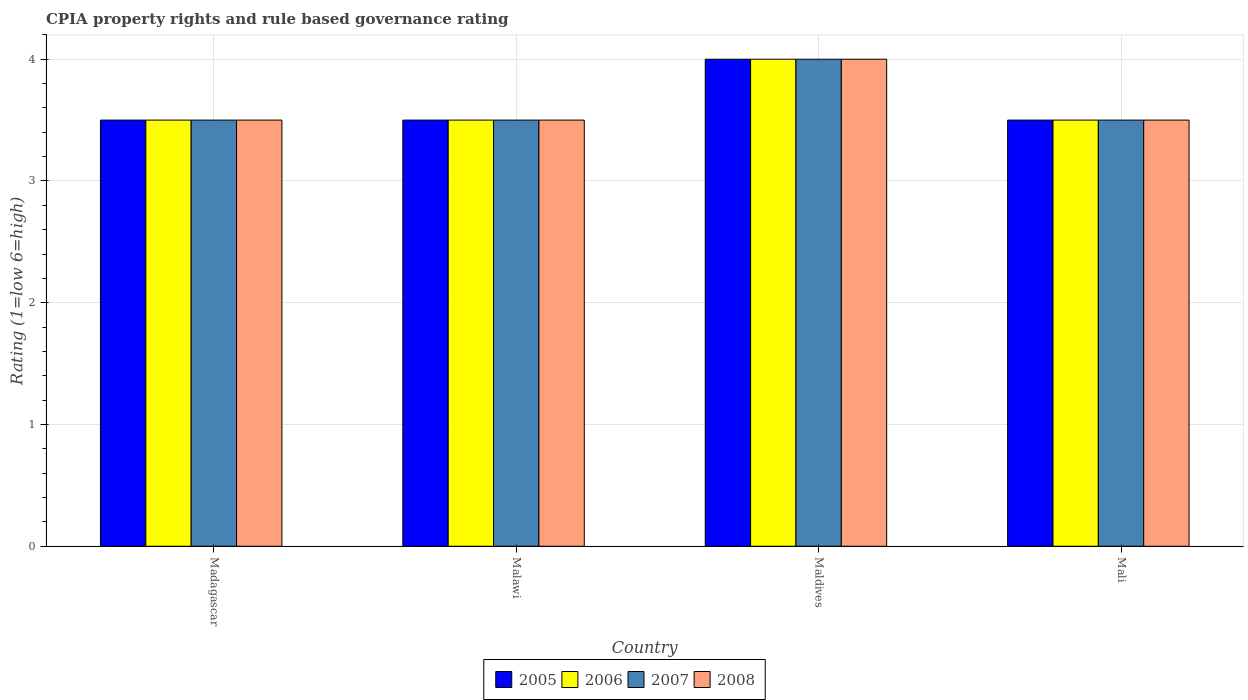How many groups of bars are there?
Offer a terse response. 4. How many bars are there on the 4th tick from the left?
Ensure brevity in your answer.  4. How many bars are there on the 1st tick from the right?
Your response must be concise. 4. What is the label of the 1st group of bars from the left?
Give a very brief answer. Madagascar. In how many cases, is the number of bars for a given country not equal to the number of legend labels?
Ensure brevity in your answer.  0. In which country was the CPIA rating in 2005 maximum?
Your answer should be very brief. Maldives. In which country was the CPIA rating in 2007 minimum?
Your response must be concise. Madagascar. What is the total CPIA rating in 2006 in the graph?
Offer a terse response. 14.5. What is the difference between the CPIA rating in 2007 in Mali and the CPIA rating in 2008 in Madagascar?
Provide a succinct answer. 0. What is the average CPIA rating in 2007 per country?
Your answer should be compact. 3.62. What is the difference between the CPIA rating of/in 2008 and CPIA rating of/in 2005 in Maldives?
Give a very brief answer. 0. In how many countries, is the CPIA rating in 2006 greater than 2.4?
Offer a very short reply. 4. What is the difference between the highest and the second highest CPIA rating in 2007?
Keep it short and to the point. -0.5. What is the difference between the highest and the lowest CPIA rating in 2005?
Your answer should be very brief. 0.5. In how many countries, is the CPIA rating in 2008 greater than the average CPIA rating in 2008 taken over all countries?
Give a very brief answer. 1. Is it the case that in every country, the sum of the CPIA rating in 2008 and CPIA rating in 2005 is greater than the sum of CPIA rating in 2006 and CPIA rating in 2007?
Your answer should be compact. No. What does the 2nd bar from the left in Mali represents?
Offer a very short reply. 2006. Are the values on the major ticks of Y-axis written in scientific E-notation?
Give a very brief answer. No. Where does the legend appear in the graph?
Offer a very short reply. Bottom center. How many legend labels are there?
Offer a very short reply. 4. How are the legend labels stacked?
Your answer should be compact. Horizontal. What is the title of the graph?
Your answer should be very brief. CPIA property rights and rule based governance rating. Does "1977" appear as one of the legend labels in the graph?
Offer a very short reply. No. What is the label or title of the X-axis?
Your answer should be very brief. Country. What is the Rating (1=low 6=high) of 2006 in Madagascar?
Keep it short and to the point. 3.5. What is the Rating (1=low 6=high) in 2007 in Madagascar?
Provide a succinct answer. 3.5. What is the Rating (1=low 6=high) of 2008 in Madagascar?
Your answer should be very brief. 3.5. What is the Rating (1=low 6=high) in 2005 in Malawi?
Give a very brief answer. 3.5. What is the Rating (1=low 6=high) of 2006 in Malawi?
Provide a short and direct response. 3.5. What is the Rating (1=low 6=high) in 2007 in Malawi?
Provide a short and direct response. 3.5. What is the Rating (1=low 6=high) of 2008 in Malawi?
Offer a terse response. 3.5. What is the Rating (1=low 6=high) in 2005 in Maldives?
Your response must be concise. 4. What is the Rating (1=low 6=high) in 2006 in Maldives?
Offer a very short reply. 4. What is the Rating (1=low 6=high) of 2005 in Mali?
Provide a succinct answer. 3.5. What is the Rating (1=low 6=high) in 2006 in Mali?
Give a very brief answer. 3.5. Across all countries, what is the maximum Rating (1=low 6=high) in 2006?
Keep it short and to the point. 4. Across all countries, what is the maximum Rating (1=low 6=high) of 2008?
Offer a terse response. 4. Across all countries, what is the minimum Rating (1=low 6=high) in 2006?
Your response must be concise. 3.5. What is the total Rating (1=low 6=high) in 2005 in the graph?
Keep it short and to the point. 14.5. What is the total Rating (1=low 6=high) in 2007 in the graph?
Provide a succinct answer. 14.5. What is the total Rating (1=low 6=high) of 2008 in the graph?
Provide a succinct answer. 14.5. What is the difference between the Rating (1=low 6=high) of 2006 in Madagascar and that in Malawi?
Offer a very short reply. 0. What is the difference between the Rating (1=low 6=high) in 2005 in Madagascar and that in Maldives?
Make the answer very short. -0.5. What is the difference between the Rating (1=low 6=high) of 2006 in Madagascar and that in Maldives?
Your response must be concise. -0.5. What is the difference between the Rating (1=low 6=high) in 2008 in Madagascar and that in Maldives?
Your answer should be very brief. -0.5. What is the difference between the Rating (1=low 6=high) in 2005 in Madagascar and that in Mali?
Your answer should be very brief. 0. What is the difference between the Rating (1=low 6=high) in 2006 in Madagascar and that in Mali?
Offer a terse response. 0. What is the difference between the Rating (1=low 6=high) of 2007 in Madagascar and that in Mali?
Your answer should be very brief. 0. What is the difference between the Rating (1=low 6=high) in 2008 in Madagascar and that in Mali?
Your response must be concise. 0. What is the difference between the Rating (1=low 6=high) in 2007 in Malawi and that in Maldives?
Provide a succinct answer. -0.5. What is the difference between the Rating (1=low 6=high) of 2006 in Malawi and that in Mali?
Your answer should be very brief. 0. What is the difference between the Rating (1=low 6=high) in 2007 in Malawi and that in Mali?
Provide a short and direct response. 0. What is the difference between the Rating (1=low 6=high) in 2008 in Malawi and that in Mali?
Your answer should be compact. 0. What is the difference between the Rating (1=low 6=high) in 2005 in Maldives and that in Mali?
Ensure brevity in your answer.  0.5. What is the difference between the Rating (1=low 6=high) in 2006 in Maldives and that in Mali?
Provide a short and direct response. 0.5. What is the difference between the Rating (1=low 6=high) in 2008 in Maldives and that in Mali?
Provide a succinct answer. 0.5. What is the difference between the Rating (1=low 6=high) of 2005 in Madagascar and the Rating (1=low 6=high) of 2006 in Malawi?
Your answer should be very brief. 0. What is the difference between the Rating (1=low 6=high) in 2005 in Madagascar and the Rating (1=low 6=high) in 2007 in Malawi?
Provide a short and direct response. 0. What is the difference between the Rating (1=low 6=high) in 2005 in Madagascar and the Rating (1=low 6=high) in 2008 in Malawi?
Provide a short and direct response. 0. What is the difference between the Rating (1=low 6=high) of 2006 in Madagascar and the Rating (1=low 6=high) of 2008 in Malawi?
Your answer should be very brief. 0. What is the difference between the Rating (1=low 6=high) of 2007 in Madagascar and the Rating (1=low 6=high) of 2008 in Malawi?
Make the answer very short. 0. What is the difference between the Rating (1=low 6=high) of 2005 in Madagascar and the Rating (1=low 6=high) of 2006 in Maldives?
Offer a very short reply. -0.5. What is the difference between the Rating (1=low 6=high) of 2005 in Madagascar and the Rating (1=low 6=high) of 2008 in Maldives?
Provide a succinct answer. -0.5. What is the difference between the Rating (1=low 6=high) of 2006 in Madagascar and the Rating (1=low 6=high) of 2007 in Maldives?
Provide a short and direct response. -0.5. What is the difference between the Rating (1=low 6=high) of 2006 in Madagascar and the Rating (1=low 6=high) of 2008 in Maldives?
Make the answer very short. -0.5. What is the difference between the Rating (1=low 6=high) of 2007 in Madagascar and the Rating (1=low 6=high) of 2008 in Maldives?
Provide a short and direct response. -0.5. What is the difference between the Rating (1=low 6=high) in 2005 in Madagascar and the Rating (1=low 6=high) in 2006 in Mali?
Give a very brief answer. 0. What is the difference between the Rating (1=low 6=high) in 2007 in Madagascar and the Rating (1=low 6=high) in 2008 in Mali?
Offer a terse response. 0. What is the difference between the Rating (1=low 6=high) of 2005 in Malawi and the Rating (1=low 6=high) of 2006 in Maldives?
Ensure brevity in your answer.  -0.5. What is the difference between the Rating (1=low 6=high) in 2005 in Malawi and the Rating (1=low 6=high) in 2008 in Maldives?
Your response must be concise. -0.5. What is the difference between the Rating (1=low 6=high) in 2006 in Malawi and the Rating (1=low 6=high) in 2008 in Maldives?
Your answer should be compact. -0.5. What is the difference between the Rating (1=low 6=high) in 2007 in Malawi and the Rating (1=low 6=high) in 2008 in Maldives?
Provide a succinct answer. -0.5. What is the difference between the Rating (1=low 6=high) of 2005 in Malawi and the Rating (1=low 6=high) of 2007 in Mali?
Your answer should be compact. 0. What is the difference between the Rating (1=low 6=high) in 2005 in Malawi and the Rating (1=low 6=high) in 2008 in Mali?
Offer a terse response. 0. What is the difference between the Rating (1=low 6=high) in 2006 in Malawi and the Rating (1=low 6=high) in 2007 in Mali?
Ensure brevity in your answer.  0. What is the difference between the Rating (1=low 6=high) of 2007 in Malawi and the Rating (1=low 6=high) of 2008 in Mali?
Provide a succinct answer. 0. What is the difference between the Rating (1=low 6=high) of 2005 in Maldives and the Rating (1=low 6=high) of 2006 in Mali?
Offer a very short reply. 0.5. What is the difference between the Rating (1=low 6=high) in 2006 in Maldives and the Rating (1=low 6=high) in 2008 in Mali?
Ensure brevity in your answer.  0.5. What is the average Rating (1=low 6=high) in 2005 per country?
Ensure brevity in your answer.  3.62. What is the average Rating (1=low 6=high) in 2006 per country?
Provide a succinct answer. 3.62. What is the average Rating (1=low 6=high) of 2007 per country?
Provide a short and direct response. 3.62. What is the average Rating (1=low 6=high) of 2008 per country?
Offer a terse response. 3.62. What is the difference between the Rating (1=low 6=high) of 2005 and Rating (1=low 6=high) of 2006 in Madagascar?
Your answer should be compact. 0. What is the difference between the Rating (1=low 6=high) in 2005 and Rating (1=low 6=high) in 2007 in Madagascar?
Your answer should be very brief. 0. What is the difference between the Rating (1=low 6=high) of 2005 and Rating (1=low 6=high) of 2008 in Maldives?
Make the answer very short. 0. What is the difference between the Rating (1=low 6=high) of 2006 and Rating (1=low 6=high) of 2007 in Maldives?
Provide a short and direct response. 0. What is the difference between the Rating (1=low 6=high) of 2006 and Rating (1=low 6=high) of 2008 in Maldives?
Your answer should be very brief. 0. What is the difference between the Rating (1=low 6=high) in 2005 and Rating (1=low 6=high) in 2008 in Mali?
Offer a very short reply. 0. What is the difference between the Rating (1=low 6=high) of 2006 and Rating (1=low 6=high) of 2008 in Mali?
Make the answer very short. 0. What is the ratio of the Rating (1=low 6=high) in 2005 in Madagascar to that in Malawi?
Ensure brevity in your answer.  1. What is the ratio of the Rating (1=low 6=high) of 2006 in Madagascar to that in Malawi?
Your response must be concise. 1. What is the ratio of the Rating (1=low 6=high) of 2007 in Madagascar to that in Malawi?
Give a very brief answer. 1. What is the ratio of the Rating (1=low 6=high) in 2008 in Madagascar to that in Malawi?
Ensure brevity in your answer.  1. What is the ratio of the Rating (1=low 6=high) in 2005 in Madagascar to that in Maldives?
Keep it short and to the point. 0.88. What is the ratio of the Rating (1=low 6=high) of 2006 in Madagascar to that in Maldives?
Make the answer very short. 0.88. What is the ratio of the Rating (1=low 6=high) of 2005 in Madagascar to that in Mali?
Your answer should be very brief. 1. What is the ratio of the Rating (1=low 6=high) of 2006 in Madagascar to that in Mali?
Offer a very short reply. 1. What is the ratio of the Rating (1=low 6=high) of 2007 in Madagascar to that in Mali?
Make the answer very short. 1. What is the ratio of the Rating (1=low 6=high) of 2007 in Malawi to that in Maldives?
Provide a short and direct response. 0.88. What is the ratio of the Rating (1=low 6=high) of 2008 in Malawi to that in Maldives?
Ensure brevity in your answer.  0.88. What is the ratio of the Rating (1=low 6=high) in 2008 in Malawi to that in Mali?
Your answer should be very brief. 1. What is the ratio of the Rating (1=low 6=high) of 2005 in Maldives to that in Mali?
Keep it short and to the point. 1.14. What is the ratio of the Rating (1=low 6=high) of 2006 in Maldives to that in Mali?
Make the answer very short. 1.14. What is the ratio of the Rating (1=low 6=high) in 2007 in Maldives to that in Mali?
Your answer should be very brief. 1.14. What is the difference between the highest and the second highest Rating (1=low 6=high) of 2005?
Give a very brief answer. 0.5. What is the difference between the highest and the lowest Rating (1=low 6=high) in 2008?
Your answer should be compact. 0.5. 